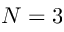<formula> <loc_0><loc_0><loc_500><loc_500>N = 3</formula> 